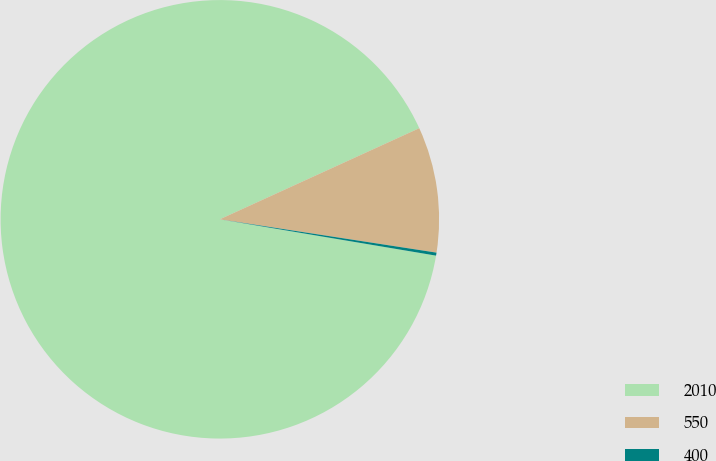<chart> <loc_0><loc_0><loc_500><loc_500><pie_chart><fcel>2010<fcel>550<fcel>400<nl><fcel>90.53%<fcel>9.25%<fcel>0.22%<nl></chart> 